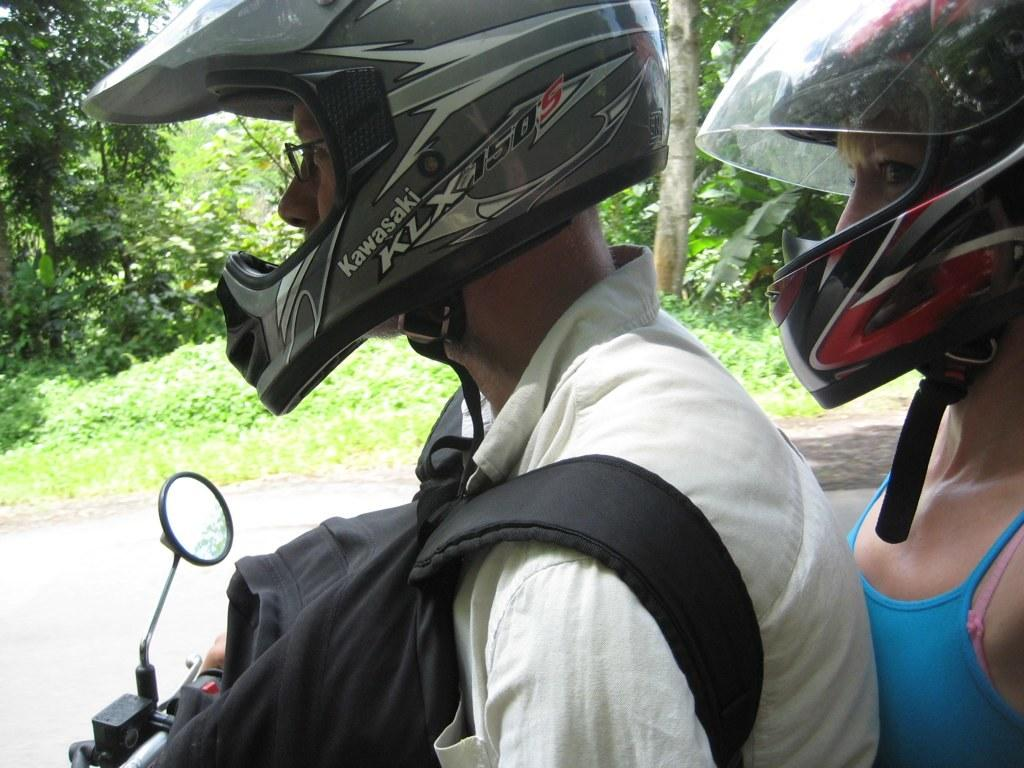How many people are in the image? There are two persons in the image. What are the persons wearing on their heads? Both persons are wearing helmets. What is unique about the person in front? The person in front is wearing glasses. What is the person in front holding? The person in front is holding a bag. What mode of transportation is the person in front using? The person in front is on a motorcycle. What can be seen in the background of the image? There are trees in the background of the image. What type of toothbrush is the person in the image using? There is no toothbrush present in the image. What authority figure can be seen in the image? There is no authority figure present in the image. 